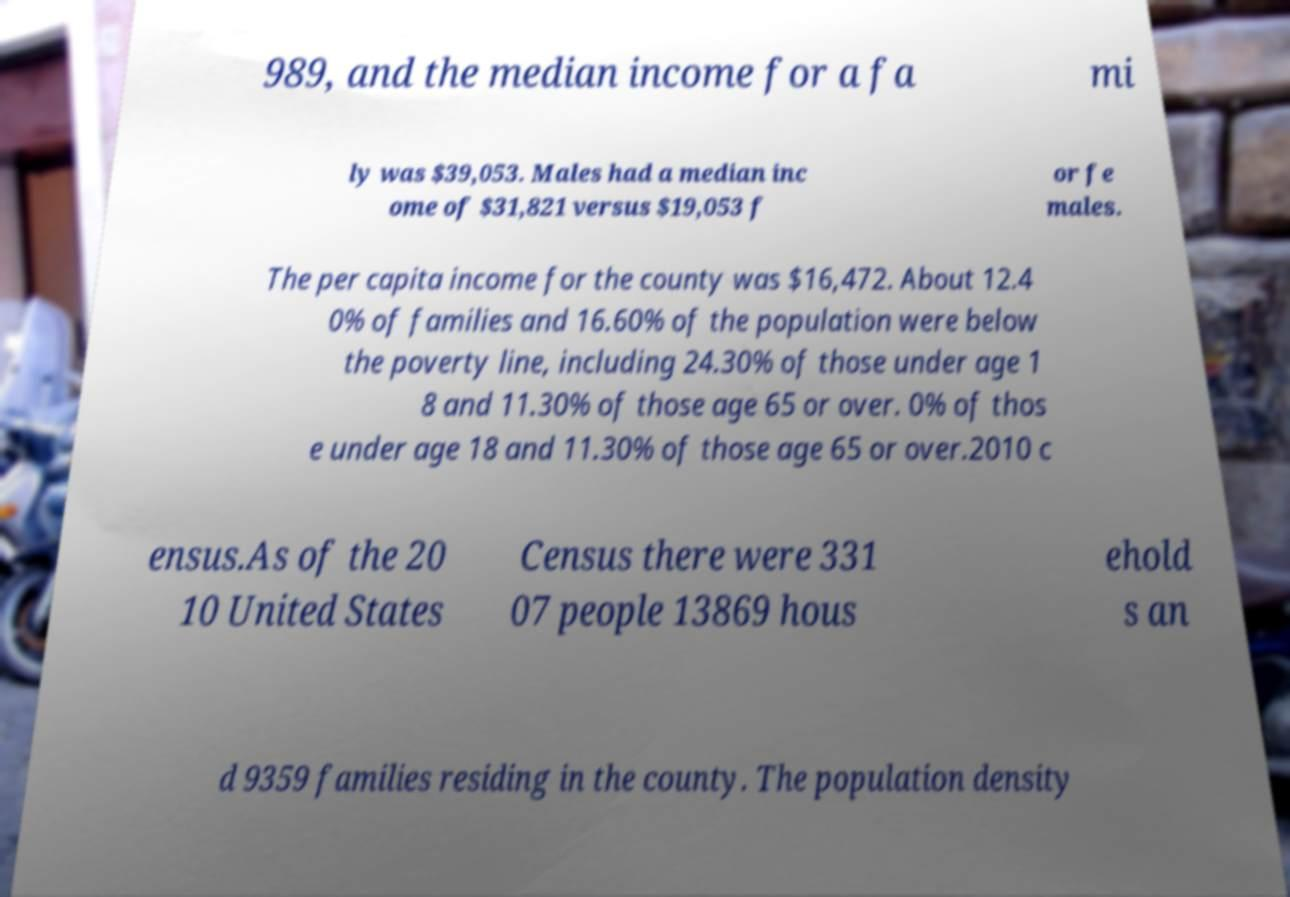What messages or text are displayed in this image? I need them in a readable, typed format. 989, and the median income for a fa mi ly was $39,053. Males had a median inc ome of $31,821 versus $19,053 f or fe males. The per capita income for the county was $16,472. About 12.4 0% of families and 16.60% of the population were below the poverty line, including 24.30% of those under age 1 8 and 11.30% of those age 65 or over. 0% of thos e under age 18 and 11.30% of those age 65 or over.2010 c ensus.As of the 20 10 United States Census there were 331 07 people 13869 hous ehold s an d 9359 families residing in the county. The population density 